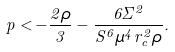Convert formula to latex. <formula><loc_0><loc_0><loc_500><loc_500>p < - \frac { 2 \rho } { 3 } - \frac { 6 \Sigma ^ { 2 } } { S ^ { 6 } \mu ^ { 4 } r _ { c } ^ { 2 } \rho } .</formula> 